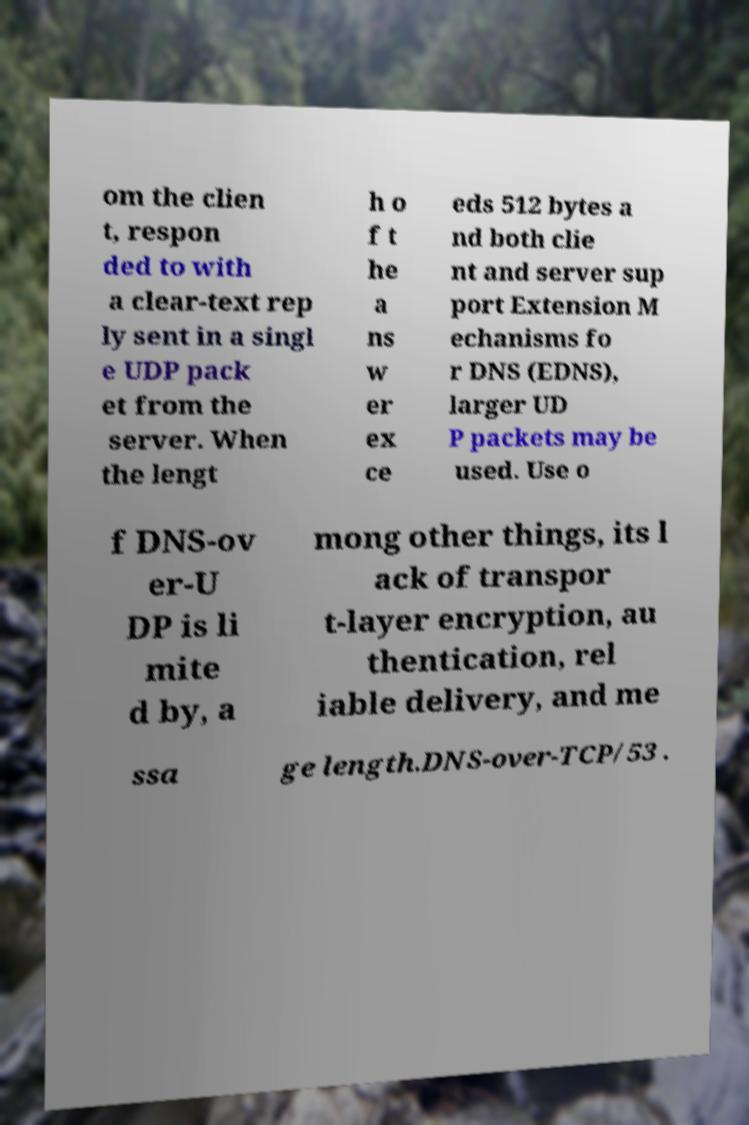Can you read and provide the text displayed in the image?This photo seems to have some interesting text. Can you extract and type it out for me? om the clien t, respon ded to with a clear-text rep ly sent in a singl e UDP pack et from the server. When the lengt h o f t he a ns w er ex ce eds 512 bytes a nd both clie nt and server sup port Extension M echanisms fo r DNS (EDNS), larger UD P packets may be used. Use o f DNS-ov er-U DP is li mite d by, a mong other things, its l ack of transpor t-layer encryption, au thentication, rel iable delivery, and me ssa ge length.DNS-over-TCP/53 . 